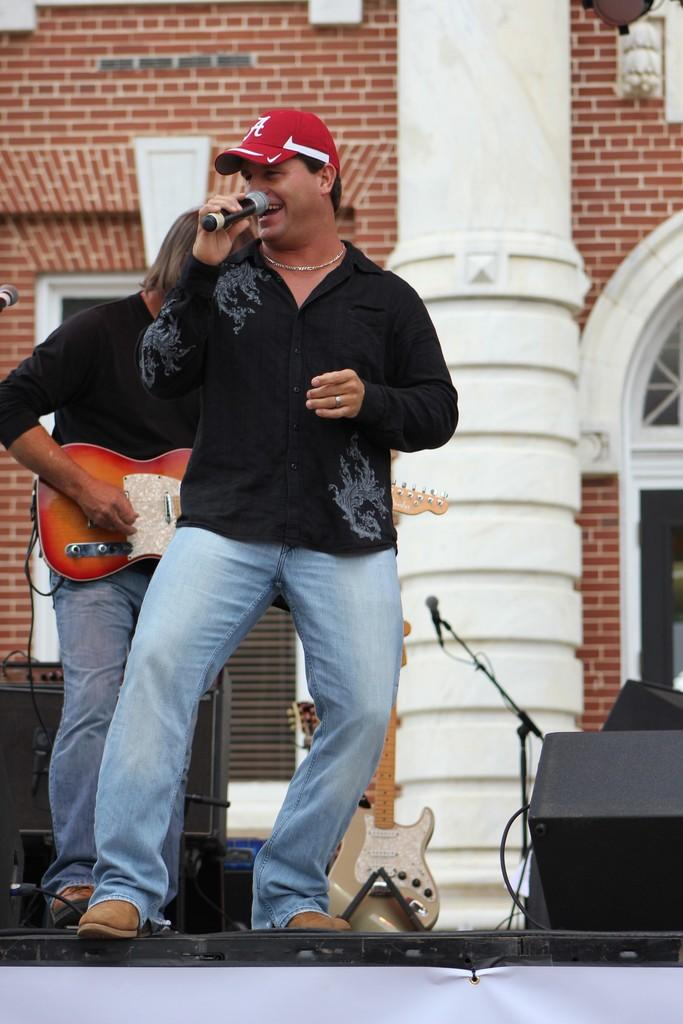What is the man in the image doing? The man is singing in the image. What object is the man holding while singing? The man is holding a microphone. What is the other person in the image doing? The person is playing a guitar. What month is it in the image? The month is not mentioned or depicted in the image. Who is the owner of the guitar in the image? The ownership of the guitar is not mentioned or depicted in the image. 